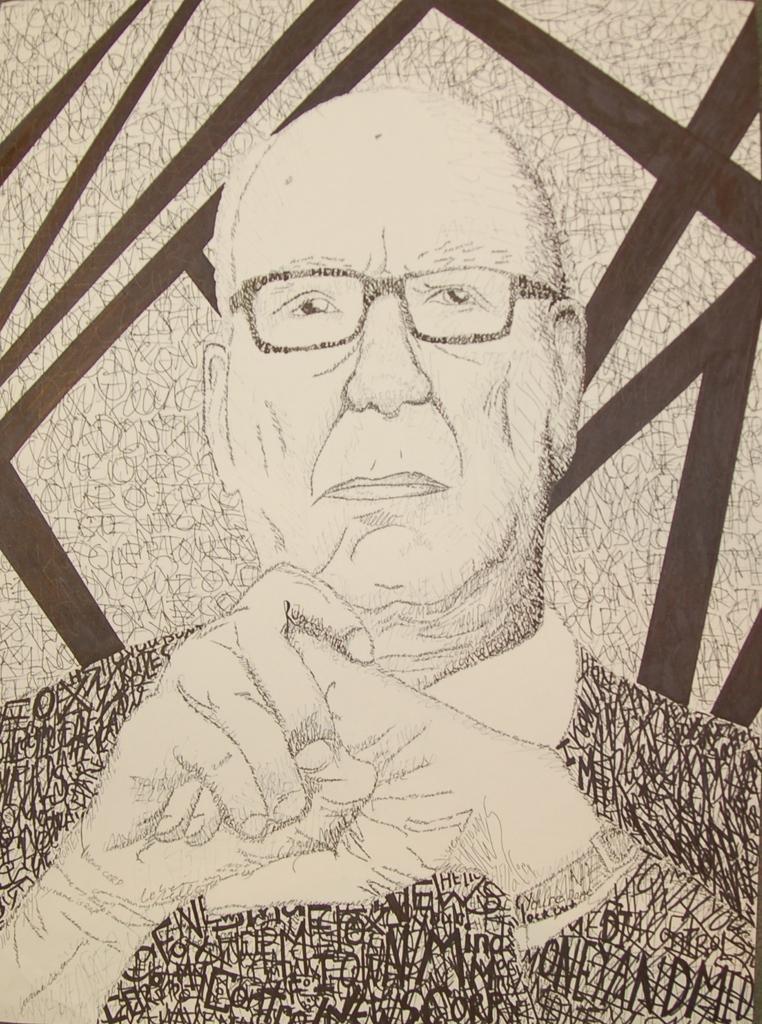Please provide a concise description of this image. In this image there is a drawing of a person wearing specs. 